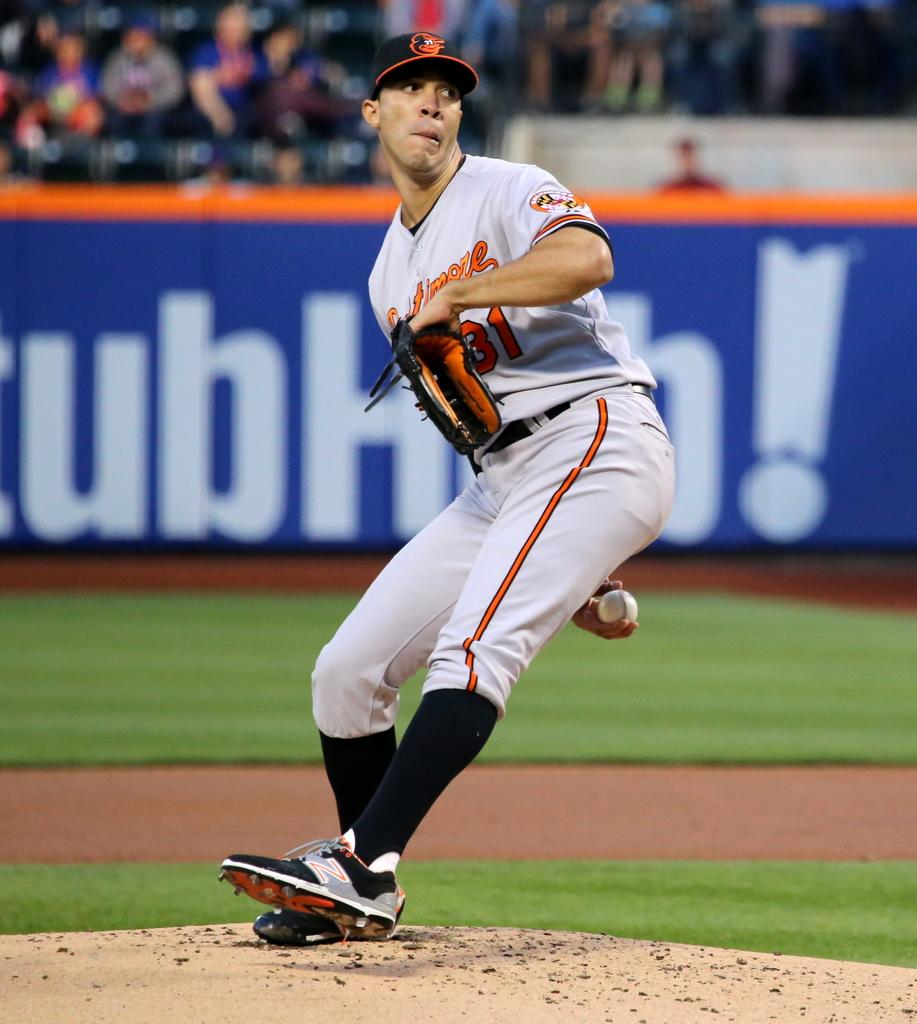<image>
Summarize the visual content of the image. A pitcher on the mound of a baseball field is about to throw the ball with a StubHub advertisement visible in the background. 